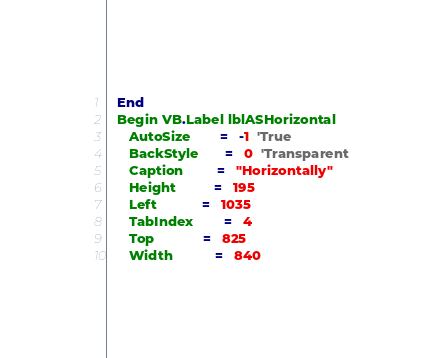Convert code to text. <code><loc_0><loc_0><loc_500><loc_500><_VisualBasic_>   End
   Begin VB.Label lblASHorizontal 
      AutoSize        =   -1  'True
      BackStyle       =   0  'Transparent
      Caption         =   "Horizontally"
      Height          =   195
      Left            =   1035
      TabIndex        =   4
      Top             =   825
      Width           =   840</code> 